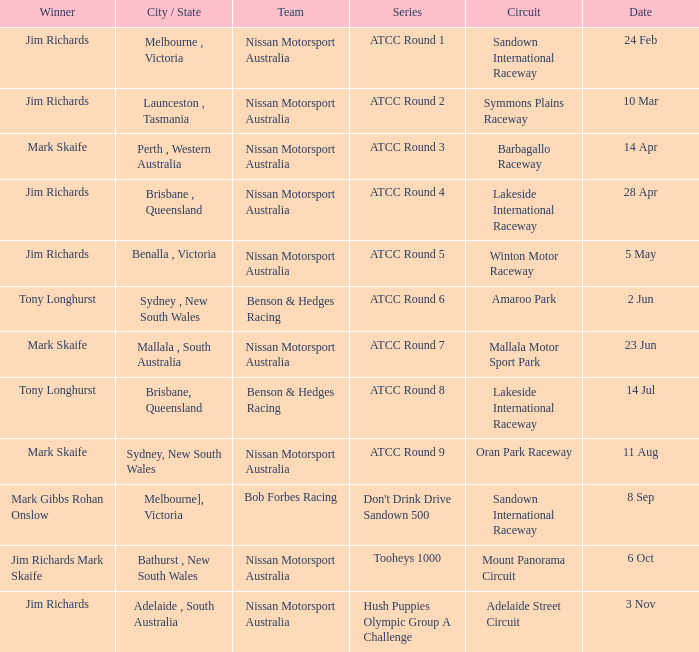Who is the Winner of the Nissan Motorsport Australia Team at the Oran Park Raceway? Mark Skaife. 